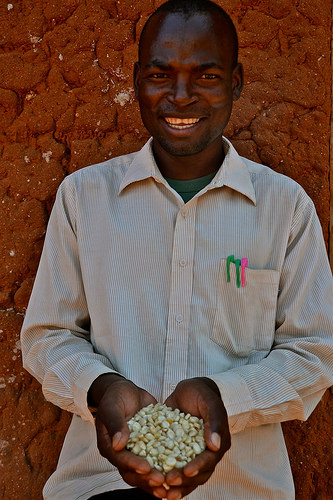<image>
Can you confirm if the man is behind the wall? No. The man is not behind the wall. From this viewpoint, the man appears to be positioned elsewhere in the scene. Is the pen next to the man? No. The pen is not positioned next to the man. They are located in different areas of the scene. 